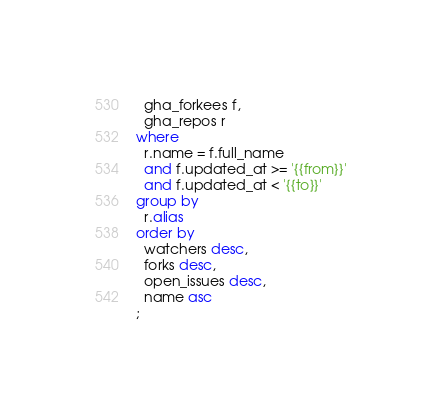<code> <loc_0><loc_0><loc_500><loc_500><_SQL_>  gha_forkees f,
  gha_repos r
where
  r.name = f.full_name
  and f.updated_at >= '{{from}}'
  and f.updated_at < '{{to}}'
group by
  r.alias
order by
  watchers desc,
  forks desc,
  open_issues desc,
  name asc
;
</code> 